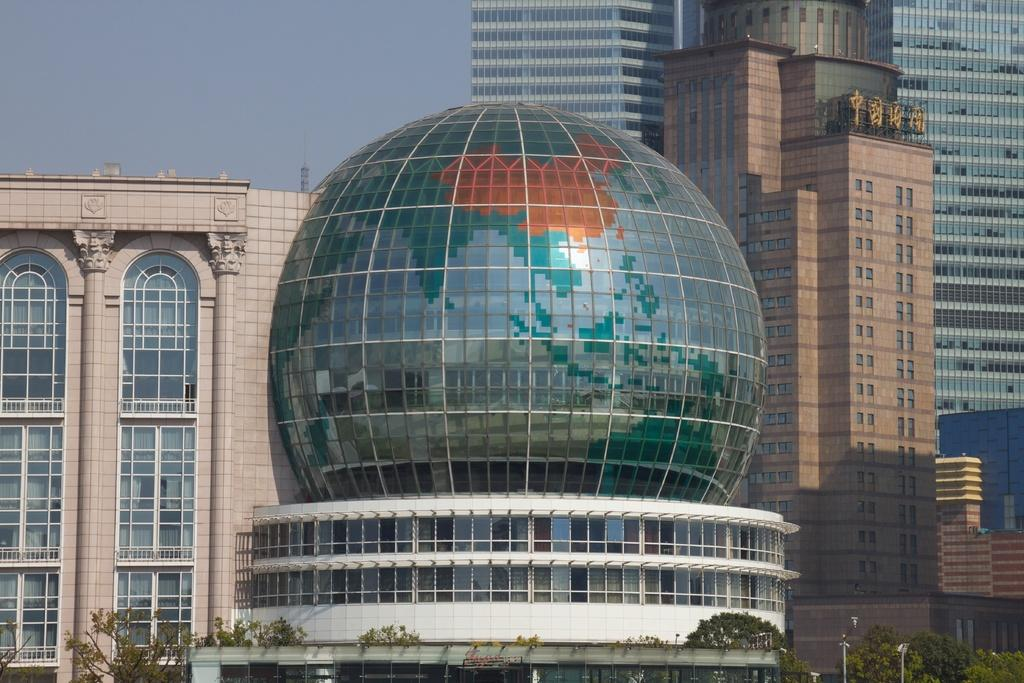What type of structures can be seen in the image? There are buildings in the image. What artistic features are present in the image? There are sculptures in the image. What type of vegetation is visible in the image? There are trees in the image. What street furniture can be seen in the image? There are street poles and street lights in the image. What type of signage is present in the image? There are name boards in the image. What part of the natural environment is visible in the image? The sky is visible in the image. How many girls are holding hands with the porter in the image? There are no girls or porters present in the image. What color are the eyes of the person in the image? There is no person visible in the image, and therefore no eyes to describe. 